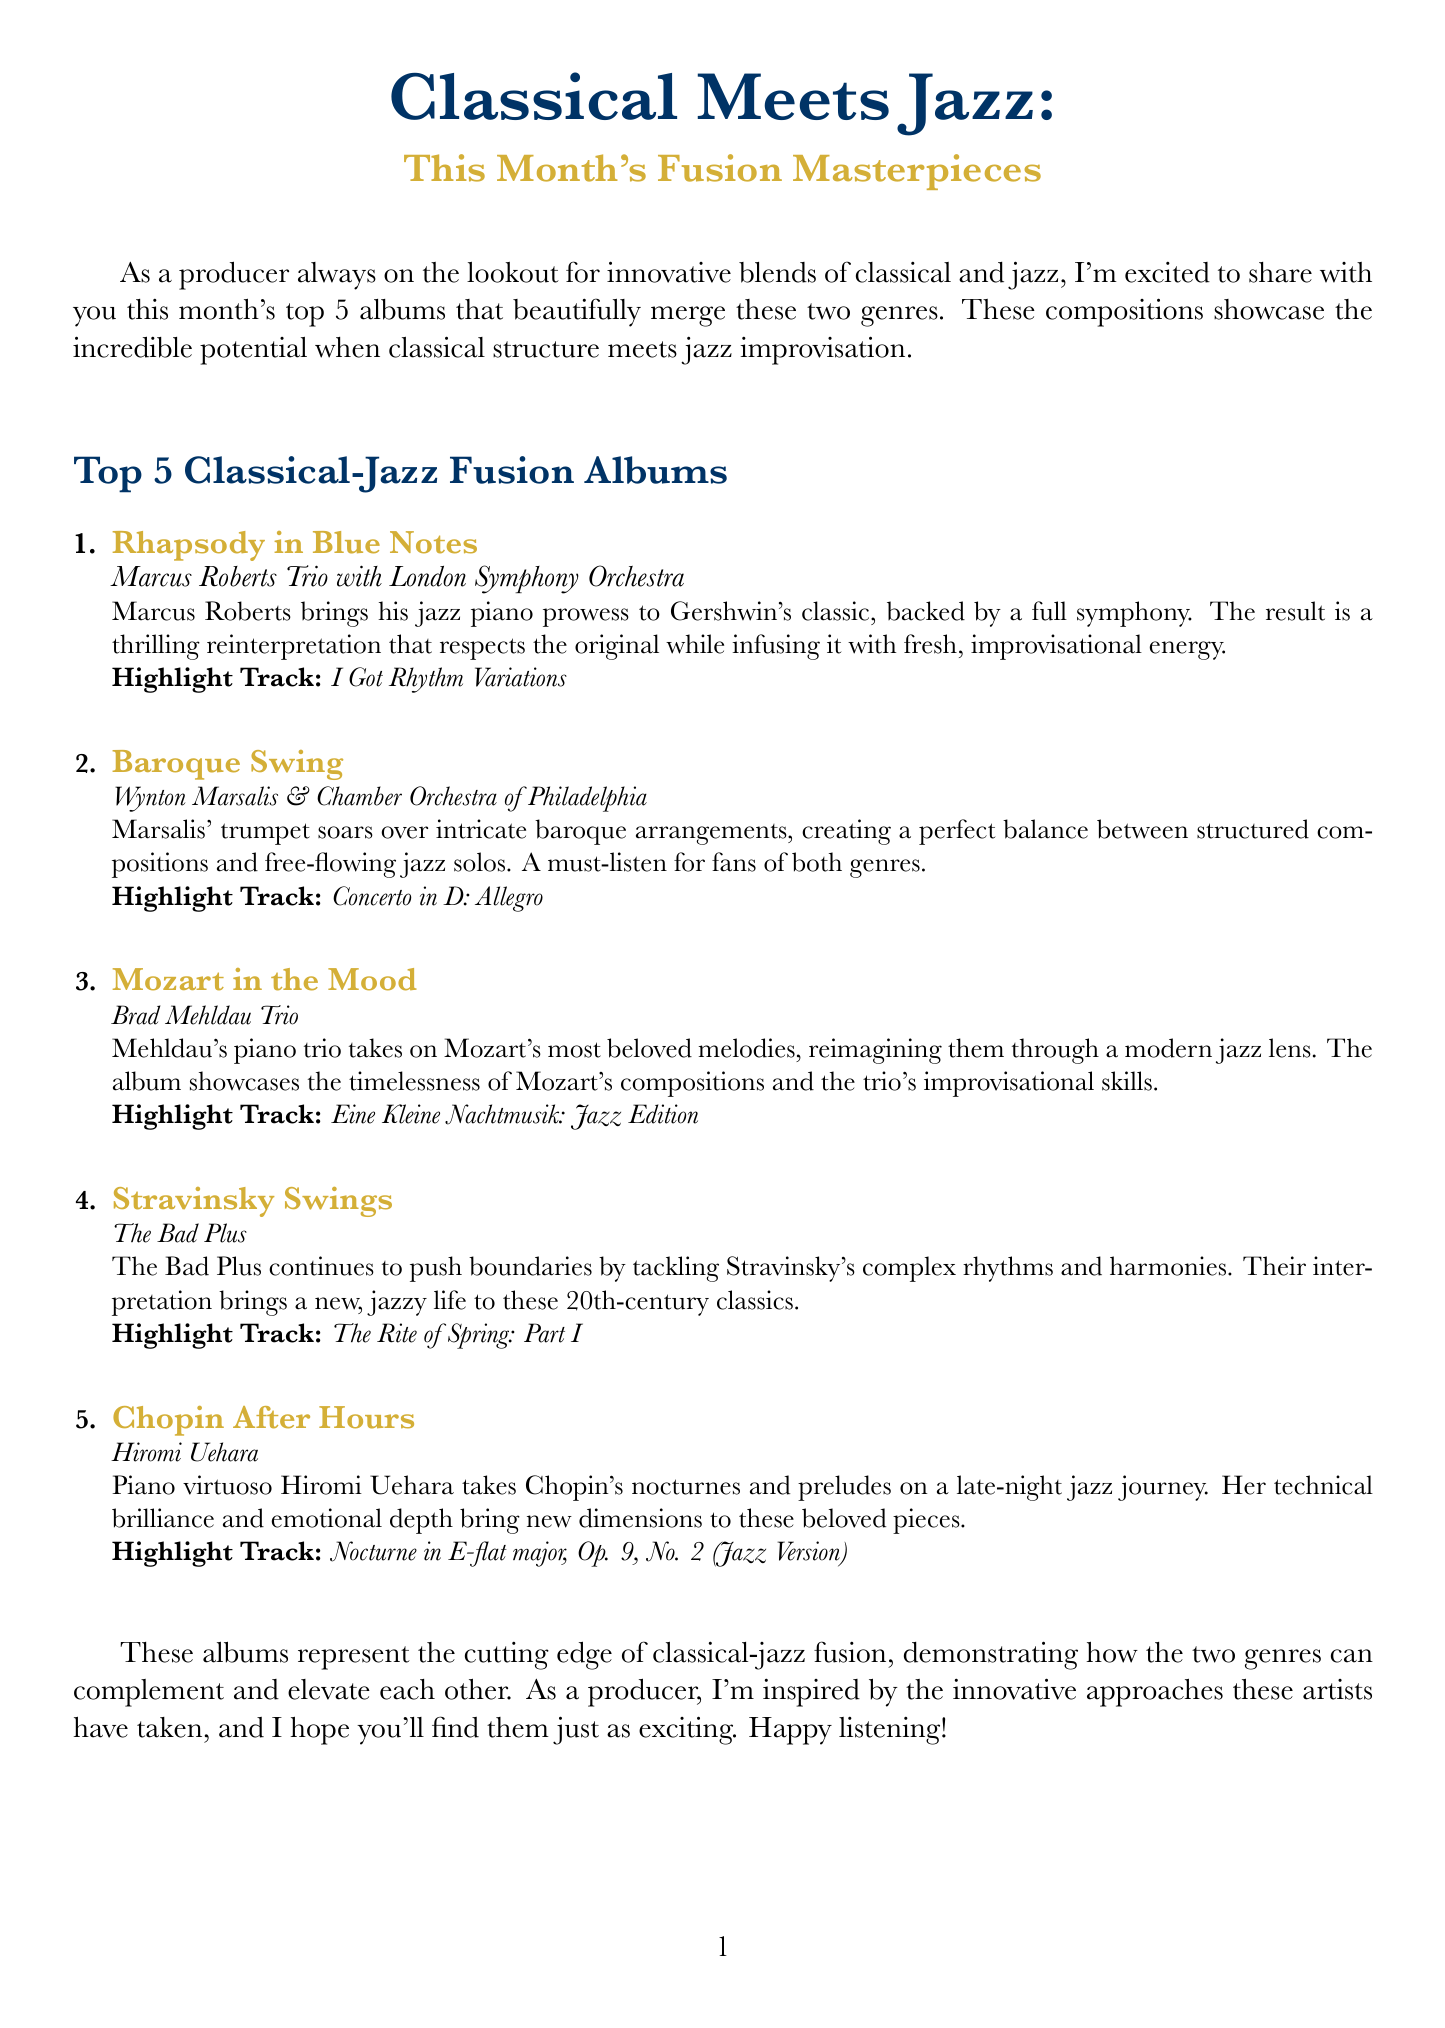What is the title of the first album? The title of the first album is listed at the top of the top albums section, which is "Rhapsody in Blue Notes".
Answer: Rhapsody in Blue Notes Who is the artist of "Chopin After Hours"? The artist of "Chopin After Hours" is mentioned clearly in the document as Hiromi Uehara.
Answer: Hiromi Uehara Which album has the highlight track "Concerto in D: Allegro"? This information can be found under the respective album title in the document, specifically mentioning "Baroque Swing".
Answer: Baroque Swing How many albums are listed in the top albums section? The total number of albums is indicated in the introduction and can be counted in the numbered list, which shows five albums.
Answer: 5 Which artist is known for pushing boundaries by tackling Stravinsky's works? The artist associated with this description in the document is "The Bad Plus", specifically noted for their innovative interpretations.
Answer: The Bad Plus What genre does the album "Mozart in the Mood" primarily interpret? The description of this album tells us that it centers around reinterpretations of Mozart's melodies.
Answer: Mozart What month’s fusion masterpieces are highlighted in this newsletter? The newsletter indicates that the discussed albums are products of the current month, which can be inferred as October from the context of the document.
Answer: October 